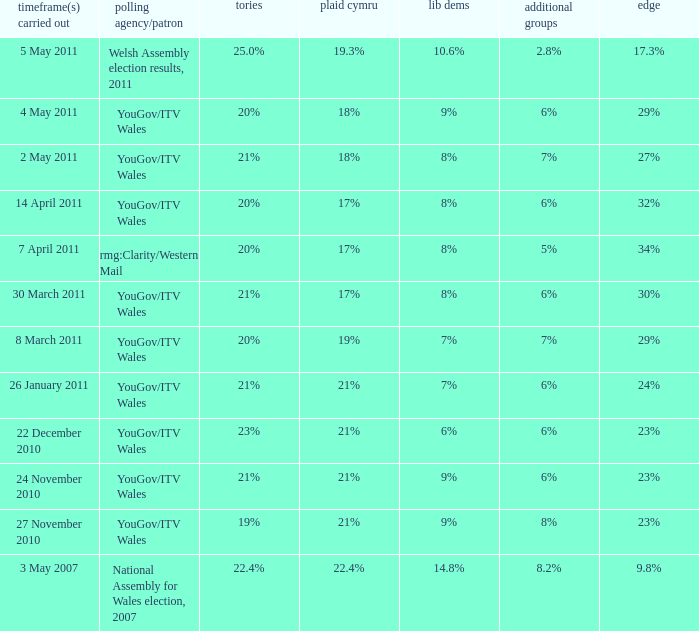I want the plaid cymru for Polling organisation/client of yougov/itv wales for 4 may 2011 18%. 